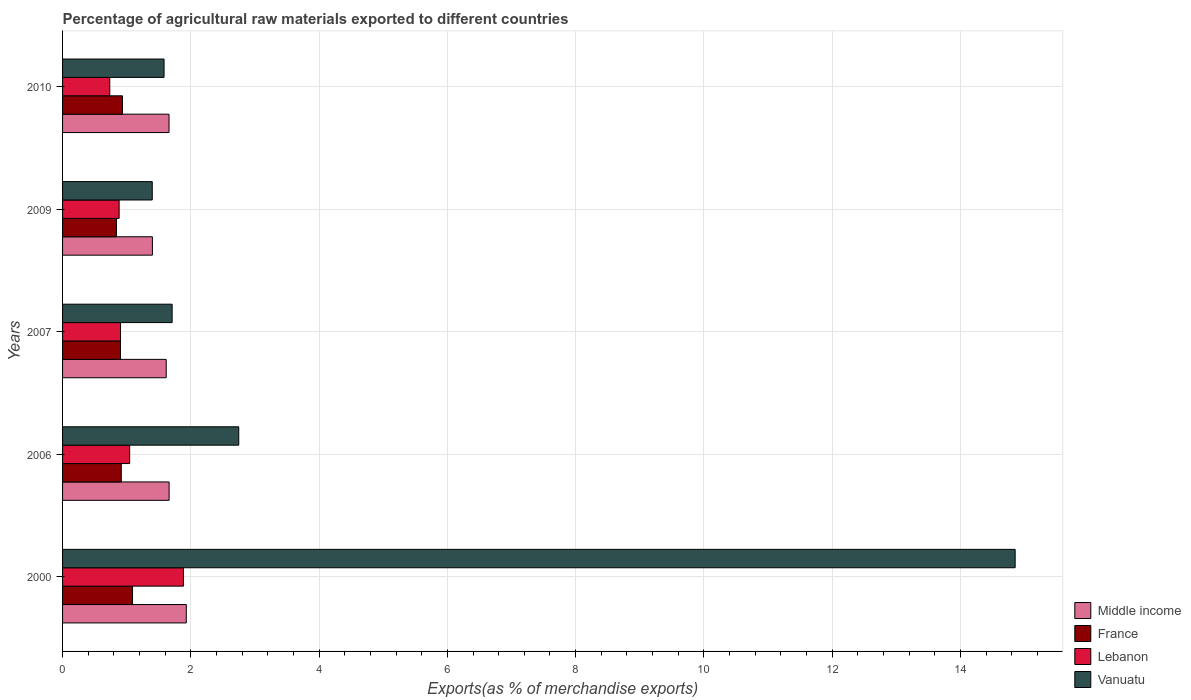How many different coloured bars are there?
Your answer should be very brief. 4. In how many cases, is the number of bars for a given year not equal to the number of legend labels?
Keep it short and to the point. 0. What is the percentage of exports to different countries in Lebanon in 2000?
Make the answer very short. 1.89. Across all years, what is the maximum percentage of exports to different countries in Lebanon?
Make the answer very short. 1.89. Across all years, what is the minimum percentage of exports to different countries in Vanuatu?
Provide a short and direct response. 1.4. In which year was the percentage of exports to different countries in Middle income maximum?
Your response must be concise. 2000. What is the total percentage of exports to different countries in Vanuatu in the graph?
Offer a terse response. 22.29. What is the difference between the percentage of exports to different countries in France in 2000 and that in 2006?
Provide a succinct answer. 0.18. What is the difference between the percentage of exports to different countries in Vanuatu in 2006 and the percentage of exports to different countries in France in 2000?
Your answer should be compact. 1.66. What is the average percentage of exports to different countries in Middle income per year?
Give a very brief answer. 1.65. In the year 2006, what is the difference between the percentage of exports to different countries in Lebanon and percentage of exports to different countries in Middle income?
Your answer should be very brief. -0.61. In how many years, is the percentage of exports to different countries in France greater than 4.8 %?
Make the answer very short. 0. What is the ratio of the percentage of exports to different countries in France in 2009 to that in 2010?
Ensure brevity in your answer.  0.9. Is the percentage of exports to different countries in Middle income in 2007 less than that in 2010?
Provide a succinct answer. Yes. Is the difference between the percentage of exports to different countries in Lebanon in 2007 and 2009 greater than the difference between the percentage of exports to different countries in Middle income in 2007 and 2009?
Provide a short and direct response. No. What is the difference between the highest and the second highest percentage of exports to different countries in Middle income?
Make the answer very short. 0.27. What is the difference between the highest and the lowest percentage of exports to different countries in Vanuatu?
Give a very brief answer. 13.45. What does the 2nd bar from the bottom in 2010 represents?
Your answer should be very brief. France. Are the values on the major ticks of X-axis written in scientific E-notation?
Make the answer very short. No. Does the graph contain any zero values?
Make the answer very short. No. Does the graph contain grids?
Offer a very short reply. Yes. Where does the legend appear in the graph?
Offer a very short reply. Bottom right. How many legend labels are there?
Give a very brief answer. 4. How are the legend labels stacked?
Offer a terse response. Vertical. What is the title of the graph?
Your answer should be compact. Percentage of agricultural raw materials exported to different countries. Does "Senegal" appear as one of the legend labels in the graph?
Ensure brevity in your answer.  No. What is the label or title of the X-axis?
Offer a terse response. Exports(as % of merchandise exports). What is the Exports(as % of merchandise exports) of Middle income in 2000?
Give a very brief answer. 1.93. What is the Exports(as % of merchandise exports) in France in 2000?
Ensure brevity in your answer.  1.09. What is the Exports(as % of merchandise exports) in Lebanon in 2000?
Offer a terse response. 1.89. What is the Exports(as % of merchandise exports) of Vanuatu in 2000?
Your answer should be very brief. 14.85. What is the Exports(as % of merchandise exports) in Middle income in 2006?
Ensure brevity in your answer.  1.66. What is the Exports(as % of merchandise exports) in France in 2006?
Offer a terse response. 0.92. What is the Exports(as % of merchandise exports) of Lebanon in 2006?
Your response must be concise. 1.05. What is the Exports(as % of merchandise exports) in Vanuatu in 2006?
Your answer should be very brief. 2.75. What is the Exports(as % of merchandise exports) in Middle income in 2007?
Offer a very short reply. 1.62. What is the Exports(as % of merchandise exports) in France in 2007?
Offer a very short reply. 0.9. What is the Exports(as % of merchandise exports) in Lebanon in 2007?
Your response must be concise. 0.9. What is the Exports(as % of merchandise exports) in Vanuatu in 2007?
Your response must be concise. 1.71. What is the Exports(as % of merchandise exports) in Middle income in 2009?
Offer a terse response. 1.4. What is the Exports(as % of merchandise exports) of France in 2009?
Your answer should be very brief. 0.84. What is the Exports(as % of merchandise exports) of Lebanon in 2009?
Your answer should be compact. 0.88. What is the Exports(as % of merchandise exports) of Vanuatu in 2009?
Make the answer very short. 1.4. What is the Exports(as % of merchandise exports) of Middle income in 2010?
Your answer should be compact. 1.66. What is the Exports(as % of merchandise exports) of France in 2010?
Keep it short and to the point. 0.93. What is the Exports(as % of merchandise exports) of Lebanon in 2010?
Offer a very short reply. 0.74. What is the Exports(as % of merchandise exports) of Vanuatu in 2010?
Your answer should be very brief. 1.58. Across all years, what is the maximum Exports(as % of merchandise exports) in Middle income?
Your answer should be very brief. 1.93. Across all years, what is the maximum Exports(as % of merchandise exports) in France?
Offer a very short reply. 1.09. Across all years, what is the maximum Exports(as % of merchandise exports) in Lebanon?
Provide a succinct answer. 1.89. Across all years, what is the maximum Exports(as % of merchandise exports) of Vanuatu?
Ensure brevity in your answer.  14.85. Across all years, what is the minimum Exports(as % of merchandise exports) in Middle income?
Provide a short and direct response. 1.4. Across all years, what is the minimum Exports(as % of merchandise exports) of France?
Offer a very short reply. 0.84. Across all years, what is the minimum Exports(as % of merchandise exports) in Lebanon?
Provide a short and direct response. 0.74. Across all years, what is the minimum Exports(as % of merchandise exports) in Vanuatu?
Give a very brief answer. 1.4. What is the total Exports(as % of merchandise exports) of Middle income in the graph?
Your answer should be compact. 8.27. What is the total Exports(as % of merchandise exports) of France in the graph?
Your response must be concise. 4.68. What is the total Exports(as % of merchandise exports) in Lebanon in the graph?
Keep it short and to the point. 5.45. What is the total Exports(as % of merchandise exports) in Vanuatu in the graph?
Your response must be concise. 22.29. What is the difference between the Exports(as % of merchandise exports) in Middle income in 2000 and that in 2006?
Keep it short and to the point. 0.27. What is the difference between the Exports(as % of merchandise exports) in France in 2000 and that in 2006?
Keep it short and to the point. 0.18. What is the difference between the Exports(as % of merchandise exports) in Lebanon in 2000 and that in 2006?
Ensure brevity in your answer.  0.84. What is the difference between the Exports(as % of merchandise exports) in Vanuatu in 2000 and that in 2006?
Your answer should be very brief. 12.11. What is the difference between the Exports(as % of merchandise exports) in Middle income in 2000 and that in 2007?
Your answer should be very brief. 0.31. What is the difference between the Exports(as % of merchandise exports) of France in 2000 and that in 2007?
Keep it short and to the point. 0.19. What is the difference between the Exports(as % of merchandise exports) of Lebanon in 2000 and that in 2007?
Make the answer very short. 0.98. What is the difference between the Exports(as % of merchandise exports) in Vanuatu in 2000 and that in 2007?
Offer a terse response. 13.14. What is the difference between the Exports(as % of merchandise exports) in Middle income in 2000 and that in 2009?
Provide a short and direct response. 0.53. What is the difference between the Exports(as % of merchandise exports) of France in 2000 and that in 2009?
Keep it short and to the point. 0.25. What is the difference between the Exports(as % of merchandise exports) of Lebanon in 2000 and that in 2009?
Offer a very short reply. 1. What is the difference between the Exports(as % of merchandise exports) in Vanuatu in 2000 and that in 2009?
Your response must be concise. 13.45. What is the difference between the Exports(as % of merchandise exports) in Middle income in 2000 and that in 2010?
Offer a terse response. 0.27. What is the difference between the Exports(as % of merchandise exports) in France in 2000 and that in 2010?
Keep it short and to the point. 0.16. What is the difference between the Exports(as % of merchandise exports) in Lebanon in 2000 and that in 2010?
Your response must be concise. 1.15. What is the difference between the Exports(as % of merchandise exports) in Vanuatu in 2000 and that in 2010?
Give a very brief answer. 13.27. What is the difference between the Exports(as % of merchandise exports) of Middle income in 2006 and that in 2007?
Offer a very short reply. 0.05. What is the difference between the Exports(as % of merchandise exports) of France in 2006 and that in 2007?
Provide a short and direct response. 0.01. What is the difference between the Exports(as % of merchandise exports) of Lebanon in 2006 and that in 2007?
Your answer should be very brief. 0.14. What is the difference between the Exports(as % of merchandise exports) of Vanuatu in 2006 and that in 2007?
Offer a terse response. 1.04. What is the difference between the Exports(as % of merchandise exports) of Middle income in 2006 and that in 2009?
Ensure brevity in your answer.  0.26. What is the difference between the Exports(as % of merchandise exports) of France in 2006 and that in 2009?
Offer a terse response. 0.08. What is the difference between the Exports(as % of merchandise exports) in Lebanon in 2006 and that in 2009?
Your answer should be compact. 0.16. What is the difference between the Exports(as % of merchandise exports) in Vanuatu in 2006 and that in 2009?
Ensure brevity in your answer.  1.35. What is the difference between the Exports(as % of merchandise exports) of Middle income in 2006 and that in 2010?
Give a very brief answer. 0. What is the difference between the Exports(as % of merchandise exports) of France in 2006 and that in 2010?
Offer a very short reply. -0.02. What is the difference between the Exports(as % of merchandise exports) in Lebanon in 2006 and that in 2010?
Provide a succinct answer. 0.31. What is the difference between the Exports(as % of merchandise exports) of Vanuatu in 2006 and that in 2010?
Offer a terse response. 1.16. What is the difference between the Exports(as % of merchandise exports) of Middle income in 2007 and that in 2009?
Your answer should be compact. 0.22. What is the difference between the Exports(as % of merchandise exports) of France in 2007 and that in 2009?
Offer a terse response. 0.06. What is the difference between the Exports(as % of merchandise exports) in Lebanon in 2007 and that in 2009?
Your answer should be very brief. 0.02. What is the difference between the Exports(as % of merchandise exports) of Vanuatu in 2007 and that in 2009?
Give a very brief answer. 0.31. What is the difference between the Exports(as % of merchandise exports) in Middle income in 2007 and that in 2010?
Offer a terse response. -0.04. What is the difference between the Exports(as % of merchandise exports) in France in 2007 and that in 2010?
Your response must be concise. -0.03. What is the difference between the Exports(as % of merchandise exports) of Lebanon in 2007 and that in 2010?
Keep it short and to the point. 0.17. What is the difference between the Exports(as % of merchandise exports) in Vanuatu in 2007 and that in 2010?
Ensure brevity in your answer.  0.13. What is the difference between the Exports(as % of merchandise exports) in Middle income in 2009 and that in 2010?
Offer a very short reply. -0.26. What is the difference between the Exports(as % of merchandise exports) in France in 2009 and that in 2010?
Your answer should be compact. -0.09. What is the difference between the Exports(as % of merchandise exports) in Lebanon in 2009 and that in 2010?
Keep it short and to the point. 0.15. What is the difference between the Exports(as % of merchandise exports) in Vanuatu in 2009 and that in 2010?
Your response must be concise. -0.18. What is the difference between the Exports(as % of merchandise exports) in Middle income in 2000 and the Exports(as % of merchandise exports) in France in 2006?
Ensure brevity in your answer.  1.01. What is the difference between the Exports(as % of merchandise exports) in Middle income in 2000 and the Exports(as % of merchandise exports) in Lebanon in 2006?
Your answer should be very brief. 0.88. What is the difference between the Exports(as % of merchandise exports) in Middle income in 2000 and the Exports(as % of merchandise exports) in Vanuatu in 2006?
Offer a very short reply. -0.82. What is the difference between the Exports(as % of merchandise exports) in France in 2000 and the Exports(as % of merchandise exports) in Lebanon in 2006?
Your answer should be compact. 0.04. What is the difference between the Exports(as % of merchandise exports) in France in 2000 and the Exports(as % of merchandise exports) in Vanuatu in 2006?
Your answer should be very brief. -1.66. What is the difference between the Exports(as % of merchandise exports) in Lebanon in 2000 and the Exports(as % of merchandise exports) in Vanuatu in 2006?
Offer a terse response. -0.86. What is the difference between the Exports(as % of merchandise exports) of Middle income in 2000 and the Exports(as % of merchandise exports) of France in 2007?
Provide a succinct answer. 1.03. What is the difference between the Exports(as % of merchandise exports) of Middle income in 2000 and the Exports(as % of merchandise exports) of Lebanon in 2007?
Your response must be concise. 1.03. What is the difference between the Exports(as % of merchandise exports) of Middle income in 2000 and the Exports(as % of merchandise exports) of Vanuatu in 2007?
Give a very brief answer. 0.22. What is the difference between the Exports(as % of merchandise exports) of France in 2000 and the Exports(as % of merchandise exports) of Lebanon in 2007?
Your response must be concise. 0.19. What is the difference between the Exports(as % of merchandise exports) of France in 2000 and the Exports(as % of merchandise exports) of Vanuatu in 2007?
Ensure brevity in your answer.  -0.62. What is the difference between the Exports(as % of merchandise exports) of Lebanon in 2000 and the Exports(as % of merchandise exports) of Vanuatu in 2007?
Keep it short and to the point. 0.18. What is the difference between the Exports(as % of merchandise exports) in Middle income in 2000 and the Exports(as % of merchandise exports) in France in 2009?
Give a very brief answer. 1.09. What is the difference between the Exports(as % of merchandise exports) in Middle income in 2000 and the Exports(as % of merchandise exports) in Lebanon in 2009?
Offer a terse response. 1.05. What is the difference between the Exports(as % of merchandise exports) in Middle income in 2000 and the Exports(as % of merchandise exports) in Vanuatu in 2009?
Give a very brief answer. 0.53. What is the difference between the Exports(as % of merchandise exports) in France in 2000 and the Exports(as % of merchandise exports) in Lebanon in 2009?
Provide a succinct answer. 0.21. What is the difference between the Exports(as % of merchandise exports) in France in 2000 and the Exports(as % of merchandise exports) in Vanuatu in 2009?
Your answer should be compact. -0.31. What is the difference between the Exports(as % of merchandise exports) of Lebanon in 2000 and the Exports(as % of merchandise exports) of Vanuatu in 2009?
Keep it short and to the point. 0.49. What is the difference between the Exports(as % of merchandise exports) in Middle income in 2000 and the Exports(as % of merchandise exports) in Lebanon in 2010?
Provide a succinct answer. 1.19. What is the difference between the Exports(as % of merchandise exports) in Middle income in 2000 and the Exports(as % of merchandise exports) in Vanuatu in 2010?
Your answer should be very brief. 0.35. What is the difference between the Exports(as % of merchandise exports) of France in 2000 and the Exports(as % of merchandise exports) of Lebanon in 2010?
Your answer should be compact. 0.35. What is the difference between the Exports(as % of merchandise exports) of France in 2000 and the Exports(as % of merchandise exports) of Vanuatu in 2010?
Your answer should be very brief. -0.49. What is the difference between the Exports(as % of merchandise exports) of Lebanon in 2000 and the Exports(as % of merchandise exports) of Vanuatu in 2010?
Offer a very short reply. 0.3. What is the difference between the Exports(as % of merchandise exports) of Middle income in 2006 and the Exports(as % of merchandise exports) of France in 2007?
Give a very brief answer. 0.76. What is the difference between the Exports(as % of merchandise exports) of Middle income in 2006 and the Exports(as % of merchandise exports) of Lebanon in 2007?
Your response must be concise. 0.76. What is the difference between the Exports(as % of merchandise exports) of Middle income in 2006 and the Exports(as % of merchandise exports) of Vanuatu in 2007?
Make the answer very short. -0.05. What is the difference between the Exports(as % of merchandise exports) of France in 2006 and the Exports(as % of merchandise exports) of Lebanon in 2007?
Your answer should be very brief. 0.01. What is the difference between the Exports(as % of merchandise exports) of France in 2006 and the Exports(as % of merchandise exports) of Vanuatu in 2007?
Make the answer very short. -0.79. What is the difference between the Exports(as % of merchandise exports) in Lebanon in 2006 and the Exports(as % of merchandise exports) in Vanuatu in 2007?
Offer a very short reply. -0.66. What is the difference between the Exports(as % of merchandise exports) of Middle income in 2006 and the Exports(as % of merchandise exports) of France in 2009?
Your answer should be compact. 0.82. What is the difference between the Exports(as % of merchandise exports) of Middle income in 2006 and the Exports(as % of merchandise exports) of Lebanon in 2009?
Your answer should be compact. 0.78. What is the difference between the Exports(as % of merchandise exports) in Middle income in 2006 and the Exports(as % of merchandise exports) in Vanuatu in 2009?
Offer a very short reply. 0.26. What is the difference between the Exports(as % of merchandise exports) of France in 2006 and the Exports(as % of merchandise exports) of Vanuatu in 2009?
Offer a terse response. -0.48. What is the difference between the Exports(as % of merchandise exports) of Lebanon in 2006 and the Exports(as % of merchandise exports) of Vanuatu in 2009?
Provide a short and direct response. -0.35. What is the difference between the Exports(as % of merchandise exports) of Middle income in 2006 and the Exports(as % of merchandise exports) of France in 2010?
Keep it short and to the point. 0.73. What is the difference between the Exports(as % of merchandise exports) in Middle income in 2006 and the Exports(as % of merchandise exports) in Lebanon in 2010?
Keep it short and to the point. 0.93. What is the difference between the Exports(as % of merchandise exports) of Middle income in 2006 and the Exports(as % of merchandise exports) of Vanuatu in 2010?
Ensure brevity in your answer.  0.08. What is the difference between the Exports(as % of merchandise exports) of France in 2006 and the Exports(as % of merchandise exports) of Lebanon in 2010?
Keep it short and to the point. 0.18. What is the difference between the Exports(as % of merchandise exports) of France in 2006 and the Exports(as % of merchandise exports) of Vanuatu in 2010?
Make the answer very short. -0.67. What is the difference between the Exports(as % of merchandise exports) of Lebanon in 2006 and the Exports(as % of merchandise exports) of Vanuatu in 2010?
Your answer should be very brief. -0.54. What is the difference between the Exports(as % of merchandise exports) in Middle income in 2007 and the Exports(as % of merchandise exports) in France in 2009?
Your answer should be very brief. 0.78. What is the difference between the Exports(as % of merchandise exports) in Middle income in 2007 and the Exports(as % of merchandise exports) in Lebanon in 2009?
Offer a very short reply. 0.73. What is the difference between the Exports(as % of merchandise exports) of Middle income in 2007 and the Exports(as % of merchandise exports) of Vanuatu in 2009?
Keep it short and to the point. 0.22. What is the difference between the Exports(as % of merchandise exports) in France in 2007 and the Exports(as % of merchandise exports) in Lebanon in 2009?
Make the answer very short. 0.02. What is the difference between the Exports(as % of merchandise exports) in France in 2007 and the Exports(as % of merchandise exports) in Vanuatu in 2009?
Keep it short and to the point. -0.5. What is the difference between the Exports(as % of merchandise exports) in Lebanon in 2007 and the Exports(as % of merchandise exports) in Vanuatu in 2009?
Keep it short and to the point. -0.49. What is the difference between the Exports(as % of merchandise exports) of Middle income in 2007 and the Exports(as % of merchandise exports) of France in 2010?
Offer a terse response. 0.68. What is the difference between the Exports(as % of merchandise exports) of Middle income in 2007 and the Exports(as % of merchandise exports) of Lebanon in 2010?
Ensure brevity in your answer.  0.88. What is the difference between the Exports(as % of merchandise exports) of Middle income in 2007 and the Exports(as % of merchandise exports) of Vanuatu in 2010?
Make the answer very short. 0.03. What is the difference between the Exports(as % of merchandise exports) of France in 2007 and the Exports(as % of merchandise exports) of Lebanon in 2010?
Ensure brevity in your answer.  0.17. What is the difference between the Exports(as % of merchandise exports) in France in 2007 and the Exports(as % of merchandise exports) in Vanuatu in 2010?
Give a very brief answer. -0.68. What is the difference between the Exports(as % of merchandise exports) of Lebanon in 2007 and the Exports(as % of merchandise exports) of Vanuatu in 2010?
Give a very brief answer. -0.68. What is the difference between the Exports(as % of merchandise exports) of Middle income in 2009 and the Exports(as % of merchandise exports) of France in 2010?
Provide a succinct answer. 0.47. What is the difference between the Exports(as % of merchandise exports) of Middle income in 2009 and the Exports(as % of merchandise exports) of Lebanon in 2010?
Make the answer very short. 0.66. What is the difference between the Exports(as % of merchandise exports) in Middle income in 2009 and the Exports(as % of merchandise exports) in Vanuatu in 2010?
Ensure brevity in your answer.  -0.18. What is the difference between the Exports(as % of merchandise exports) of France in 2009 and the Exports(as % of merchandise exports) of Lebanon in 2010?
Provide a succinct answer. 0.1. What is the difference between the Exports(as % of merchandise exports) of France in 2009 and the Exports(as % of merchandise exports) of Vanuatu in 2010?
Provide a short and direct response. -0.74. What is the difference between the Exports(as % of merchandise exports) in Lebanon in 2009 and the Exports(as % of merchandise exports) in Vanuatu in 2010?
Make the answer very short. -0.7. What is the average Exports(as % of merchandise exports) of Middle income per year?
Your response must be concise. 1.65. What is the average Exports(as % of merchandise exports) in France per year?
Make the answer very short. 0.94. What is the average Exports(as % of merchandise exports) in Lebanon per year?
Keep it short and to the point. 1.09. What is the average Exports(as % of merchandise exports) of Vanuatu per year?
Provide a succinct answer. 4.46. In the year 2000, what is the difference between the Exports(as % of merchandise exports) in Middle income and Exports(as % of merchandise exports) in France?
Offer a terse response. 0.84. In the year 2000, what is the difference between the Exports(as % of merchandise exports) in Middle income and Exports(as % of merchandise exports) in Lebanon?
Keep it short and to the point. 0.04. In the year 2000, what is the difference between the Exports(as % of merchandise exports) in Middle income and Exports(as % of merchandise exports) in Vanuatu?
Make the answer very short. -12.92. In the year 2000, what is the difference between the Exports(as % of merchandise exports) in France and Exports(as % of merchandise exports) in Lebanon?
Offer a terse response. -0.79. In the year 2000, what is the difference between the Exports(as % of merchandise exports) in France and Exports(as % of merchandise exports) in Vanuatu?
Offer a terse response. -13.76. In the year 2000, what is the difference between the Exports(as % of merchandise exports) of Lebanon and Exports(as % of merchandise exports) of Vanuatu?
Make the answer very short. -12.97. In the year 2006, what is the difference between the Exports(as % of merchandise exports) of Middle income and Exports(as % of merchandise exports) of France?
Give a very brief answer. 0.75. In the year 2006, what is the difference between the Exports(as % of merchandise exports) in Middle income and Exports(as % of merchandise exports) in Lebanon?
Keep it short and to the point. 0.61. In the year 2006, what is the difference between the Exports(as % of merchandise exports) of Middle income and Exports(as % of merchandise exports) of Vanuatu?
Ensure brevity in your answer.  -1.09. In the year 2006, what is the difference between the Exports(as % of merchandise exports) of France and Exports(as % of merchandise exports) of Lebanon?
Your response must be concise. -0.13. In the year 2006, what is the difference between the Exports(as % of merchandise exports) in France and Exports(as % of merchandise exports) in Vanuatu?
Offer a very short reply. -1.83. In the year 2006, what is the difference between the Exports(as % of merchandise exports) of Lebanon and Exports(as % of merchandise exports) of Vanuatu?
Make the answer very short. -1.7. In the year 2007, what is the difference between the Exports(as % of merchandise exports) in Middle income and Exports(as % of merchandise exports) in France?
Your answer should be compact. 0.71. In the year 2007, what is the difference between the Exports(as % of merchandise exports) in Middle income and Exports(as % of merchandise exports) in Lebanon?
Make the answer very short. 0.71. In the year 2007, what is the difference between the Exports(as % of merchandise exports) in Middle income and Exports(as % of merchandise exports) in Vanuatu?
Your answer should be very brief. -0.09. In the year 2007, what is the difference between the Exports(as % of merchandise exports) of France and Exports(as % of merchandise exports) of Lebanon?
Your response must be concise. -0. In the year 2007, what is the difference between the Exports(as % of merchandise exports) in France and Exports(as % of merchandise exports) in Vanuatu?
Provide a short and direct response. -0.81. In the year 2007, what is the difference between the Exports(as % of merchandise exports) of Lebanon and Exports(as % of merchandise exports) of Vanuatu?
Keep it short and to the point. -0.8. In the year 2009, what is the difference between the Exports(as % of merchandise exports) in Middle income and Exports(as % of merchandise exports) in France?
Provide a succinct answer. 0.56. In the year 2009, what is the difference between the Exports(as % of merchandise exports) of Middle income and Exports(as % of merchandise exports) of Lebanon?
Your answer should be compact. 0.52. In the year 2009, what is the difference between the Exports(as % of merchandise exports) of Middle income and Exports(as % of merchandise exports) of Vanuatu?
Give a very brief answer. 0. In the year 2009, what is the difference between the Exports(as % of merchandise exports) in France and Exports(as % of merchandise exports) in Lebanon?
Provide a short and direct response. -0.04. In the year 2009, what is the difference between the Exports(as % of merchandise exports) in France and Exports(as % of merchandise exports) in Vanuatu?
Keep it short and to the point. -0.56. In the year 2009, what is the difference between the Exports(as % of merchandise exports) of Lebanon and Exports(as % of merchandise exports) of Vanuatu?
Your answer should be very brief. -0.52. In the year 2010, what is the difference between the Exports(as % of merchandise exports) in Middle income and Exports(as % of merchandise exports) in France?
Your response must be concise. 0.73. In the year 2010, what is the difference between the Exports(as % of merchandise exports) in Middle income and Exports(as % of merchandise exports) in Lebanon?
Your answer should be compact. 0.92. In the year 2010, what is the difference between the Exports(as % of merchandise exports) of Middle income and Exports(as % of merchandise exports) of Vanuatu?
Offer a very short reply. 0.08. In the year 2010, what is the difference between the Exports(as % of merchandise exports) of France and Exports(as % of merchandise exports) of Lebanon?
Your answer should be very brief. 0.2. In the year 2010, what is the difference between the Exports(as % of merchandise exports) in France and Exports(as % of merchandise exports) in Vanuatu?
Your response must be concise. -0.65. In the year 2010, what is the difference between the Exports(as % of merchandise exports) of Lebanon and Exports(as % of merchandise exports) of Vanuatu?
Ensure brevity in your answer.  -0.85. What is the ratio of the Exports(as % of merchandise exports) in Middle income in 2000 to that in 2006?
Offer a terse response. 1.16. What is the ratio of the Exports(as % of merchandise exports) in France in 2000 to that in 2006?
Provide a succinct answer. 1.19. What is the ratio of the Exports(as % of merchandise exports) in Lebanon in 2000 to that in 2006?
Your response must be concise. 1.8. What is the ratio of the Exports(as % of merchandise exports) in Vanuatu in 2000 to that in 2006?
Provide a succinct answer. 5.41. What is the ratio of the Exports(as % of merchandise exports) in Middle income in 2000 to that in 2007?
Your answer should be compact. 1.19. What is the ratio of the Exports(as % of merchandise exports) of France in 2000 to that in 2007?
Offer a very short reply. 1.21. What is the ratio of the Exports(as % of merchandise exports) of Lebanon in 2000 to that in 2007?
Offer a very short reply. 2.09. What is the ratio of the Exports(as % of merchandise exports) of Vanuatu in 2000 to that in 2007?
Ensure brevity in your answer.  8.69. What is the ratio of the Exports(as % of merchandise exports) of Middle income in 2000 to that in 2009?
Provide a short and direct response. 1.38. What is the ratio of the Exports(as % of merchandise exports) of France in 2000 to that in 2009?
Keep it short and to the point. 1.3. What is the ratio of the Exports(as % of merchandise exports) in Lebanon in 2000 to that in 2009?
Provide a short and direct response. 2.14. What is the ratio of the Exports(as % of merchandise exports) of Vanuatu in 2000 to that in 2009?
Your answer should be compact. 10.62. What is the ratio of the Exports(as % of merchandise exports) in Middle income in 2000 to that in 2010?
Offer a terse response. 1.16. What is the ratio of the Exports(as % of merchandise exports) in France in 2000 to that in 2010?
Your answer should be compact. 1.17. What is the ratio of the Exports(as % of merchandise exports) in Lebanon in 2000 to that in 2010?
Make the answer very short. 2.56. What is the ratio of the Exports(as % of merchandise exports) of Vanuatu in 2000 to that in 2010?
Your answer should be very brief. 9.39. What is the ratio of the Exports(as % of merchandise exports) of Middle income in 2006 to that in 2007?
Provide a succinct answer. 1.03. What is the ratio of the Exports(as % of merchandise exports) in France in 2006 to that in 2007?
Your answer should be very brief. 1.01. What is the ratio of the Exports(as % of merchandise exports) of Lebanon in 2006 to that in 2007?
Your answer should be compact. 1.16. What is the ratio of the Exports(as % of merchandise exports) of Vanuatu in 2006 to that in 2007?
Offer a very short reply. 1.61. What is the ratio of the Exports(as % of merchandise exports) in Middle income in 2006 to that in 2009?
Your answer should be compact. 1.19. What is the ratio of the Exports(as % of merchandise exports) in France in 2006 to that in 2009?
Make the answer very short. 1.09. What is the ratio of the Exports(as % of merchandise exports) in Lebanon in 2006 to that in 2009?
Your answer should be very brief. 1.19. What is the ratio of the Exports(as % of merchandise exports) in Vanuatu in 2006 to that in 2009?
Your response must be concise. 1.96. What is the ratio of the Exports(as % of merchandise exports) of Middle income in 2006 to that in 2010?
Offer a very short reply. 1. What is the ratio of the Exports(as % of merchandise exports) of Lebanon in 2006 to that in 2010?
Your response must be concise. 1.42. What is the ratio of the Exports(as % of merchandise exports) of Vanuatu in 2006 to that in 2010?
Offer a very short reply. 1.74. What is the ratio of the Exports(as % of merchandise exports) of Middle income in 2007 to that in 2009?
Your answer should be very brief. 1.15. What is the ratio of the Exports(as % of merchandise exports) of France in 2007 to that in 2009?
Keep it short and to the point. 1.07. What is the ratio of the Exports(as % of merchandise exports) of Lebanon in 2007 to that in 2009?
Your answer should be very brief. 1.02. What is the ratio of the Exports(as % of merchandise exports) in Vanuatu in 2007 to that in 2009?
Your answer should be very brief. 1.22. What is the ratio of the Exports(as % of merchandise exports) in Middle income in 2007 to that in 2010?
Make the answer very short. 0.97. What is the ratio of the Exports(as % of merchandise exports) in France in 2007 to that in 2010?
Give a very brief answer. 0.97. What is the ratio of the Exports(as % of merchandise exports) in Lebanon in 2007 to that in 2010?
Offer a very short reply. 1.23. What is the ratio of the Exports(as % of merchandise exports) in Vanuatu in 2007 to that in 2010?
Offer a very short reply. 1.08. What is the ratio of the Exports(as % of merchandise exports) in Middle income in 2009 to that in 2010?
Your answer should be very brief. 0.84. What is the ratio of the Exports(as % of merchandise exports) in France in 2009 to that in 2010?
Provide a succinct answer. 0.9. What is the ratio of the Exports(as % of merchandise exports) in Lebanon in 2009 to that in 2010?
Ensure brevity in your answer.  1.2. What is the ratio of the Exports(as % of merchandise exports) of Vanuatu in 2009 to that in 2010?
Provide a succinct answer. 0.88. What is the difference between the highest and the second highest Exports(as % of merchandise exports) in Middle income?
Your answer should be compact. 0.27. What is the difference between the highest and the second highest Exports(as % of merchandise exports) of France?
Offer a very short reply. 0.16. What is the difference between the highest and the second highest Exports(as % of merchandise exports) in Lebanon?
Your response must be concise. 0.84. What is the difference between the highest and the second highest Exports(as % of merchandise exports) of Vanuatu?
Ensure brevity in your answer.  12.11. What is the difference between the highest and the lowest Exports(as % of merchandise exports) of Middle income?
Ensure brevity in your answer.  0.53. What is the difference between the highest and the lowest Exports(as % of merchandise exports) of France?
Offer a very short reply. 0.25. What is the difference between the highest and the lowest Exports(as % of merchandise exports) of Lebanon?
Your response must be concise. 1.15. What is the difference between the highest and the lowest Exports(as % of merchandise exports) in Vanuatu?
Make the answer very short. 13.45. 